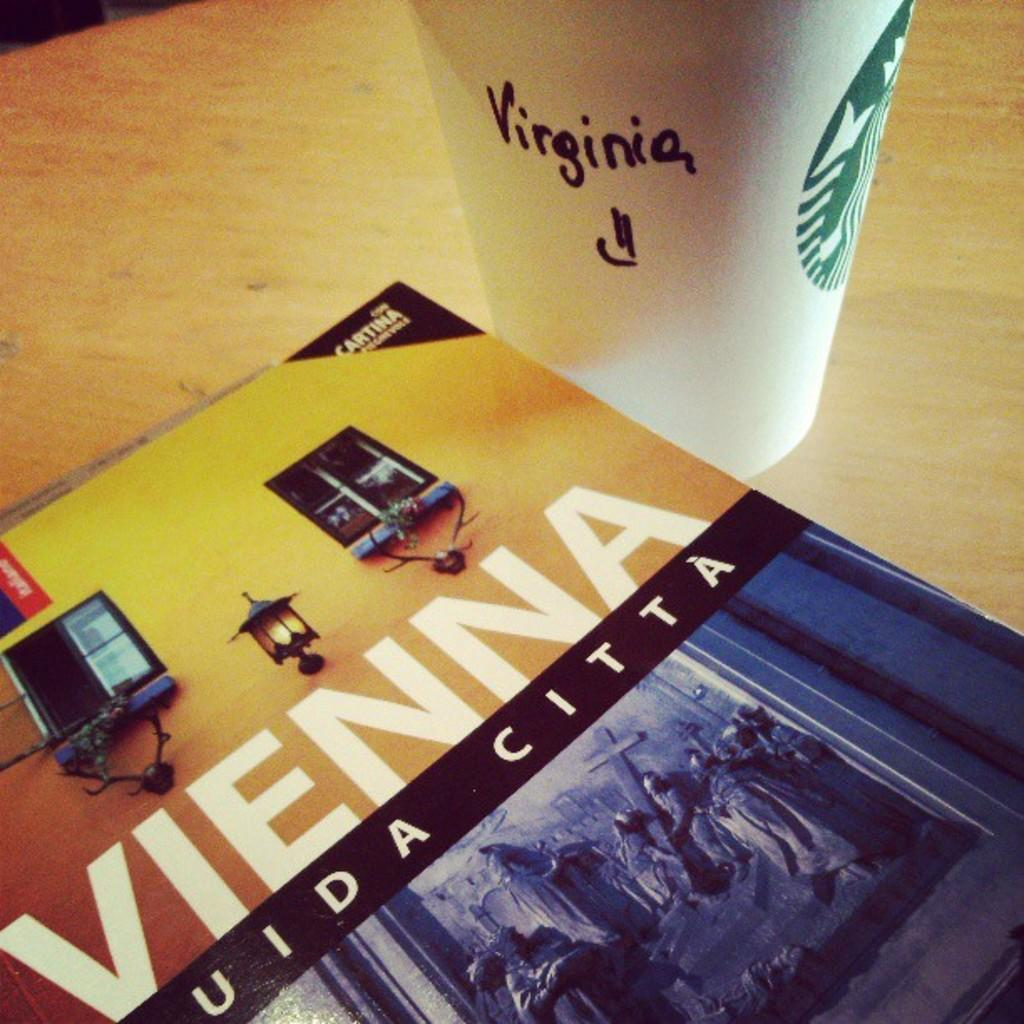Provide a one-sentence caption for the provided image. A Vienna book cover next to a Starbucks coffee cup. 